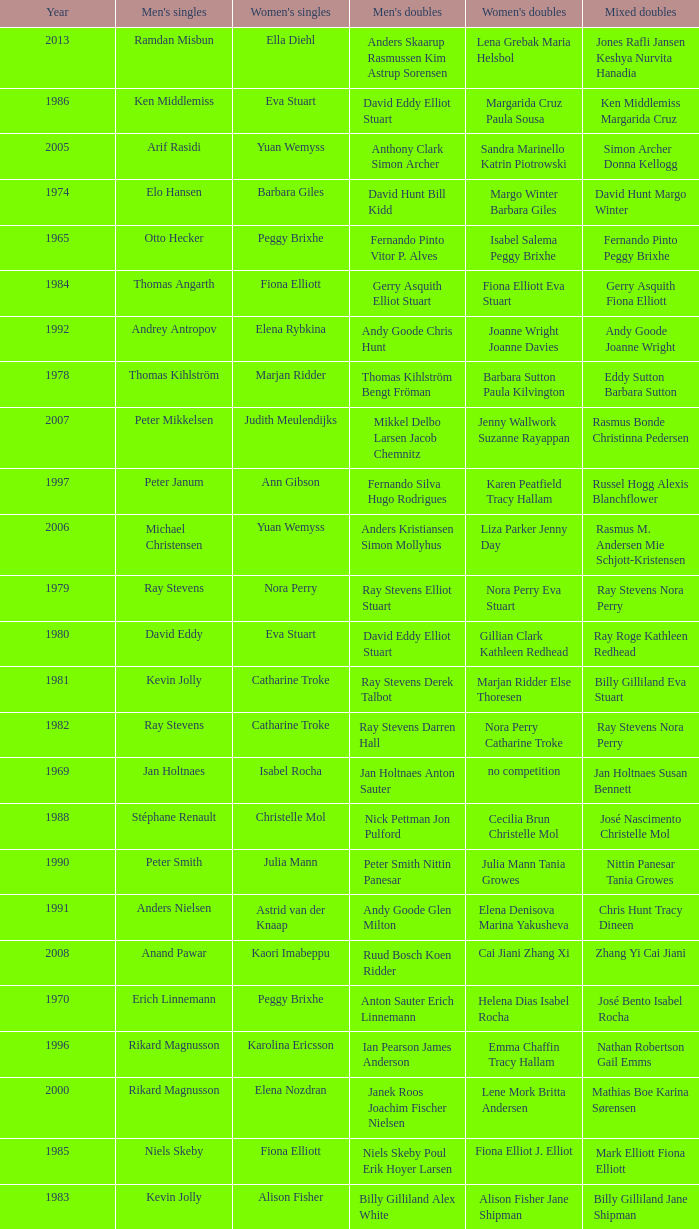What is the average year with alfredo salazar fina salazar in mixed doubles? 1971.0. 